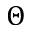Convert formula to latex. <formula><loc_0><loc_0><loc_500><loc_500>\Theta</formula> 